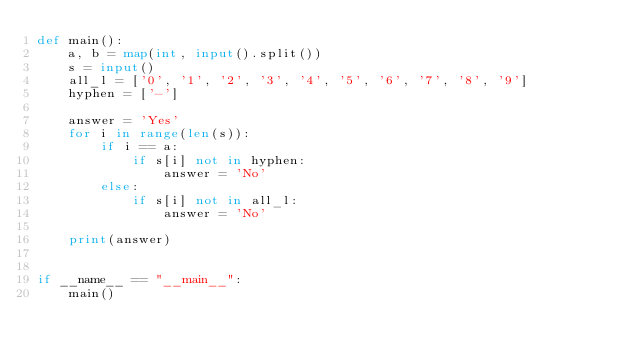<code> <loc_0><loc_0><loc_500><loc_500><_Python_>def main():
    a, b = map(int, input().split())
    s = input()
    all_l = ['0', '1', '2', '3', '4', '5', '6', '7', '8', '9']
    hyphen = ['-']

    answer = 'Yes'
    for i in range(len(s)):
        if i == a:
            if s[i] not in hyphen:
                answer = 'No'
        else:
            if s[i] not in all_l:
                answer = 'No'

    print(answer)


if __name__ == "__main__":
    main()
</code> 